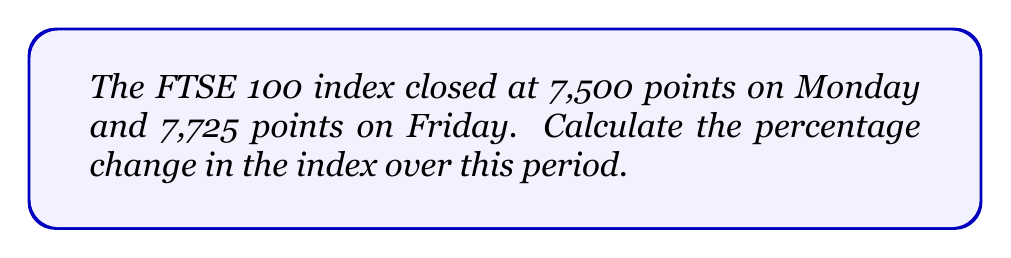Give your solution to this math problem. To calculate the percentage change in the FTSE 100 index, we need to follow these steps:

1. Calculate the change in points:
   $\text{Change} = \text{Friday's value} - \text{Monday's value}$
   $\text{Change} = 7,725 - 7,500 = 225$ points

2. Calculate the percentage change using the formula:
   $$\text{Percentage change} = \frac{\text{Change}}{\text{Original value}} \times 100\%$$

3. Substitute the values:
   $$\text{Percentage change} = \frac{225}{7,500} \times 100\%$$

4. Perform the calculation:
   $$\text{Percentage change} = 0.03 \times 100\% = 3\%$$

The FTSE 100 index increased by 3% over the period from Monday to Friday.
Answer: 3% 